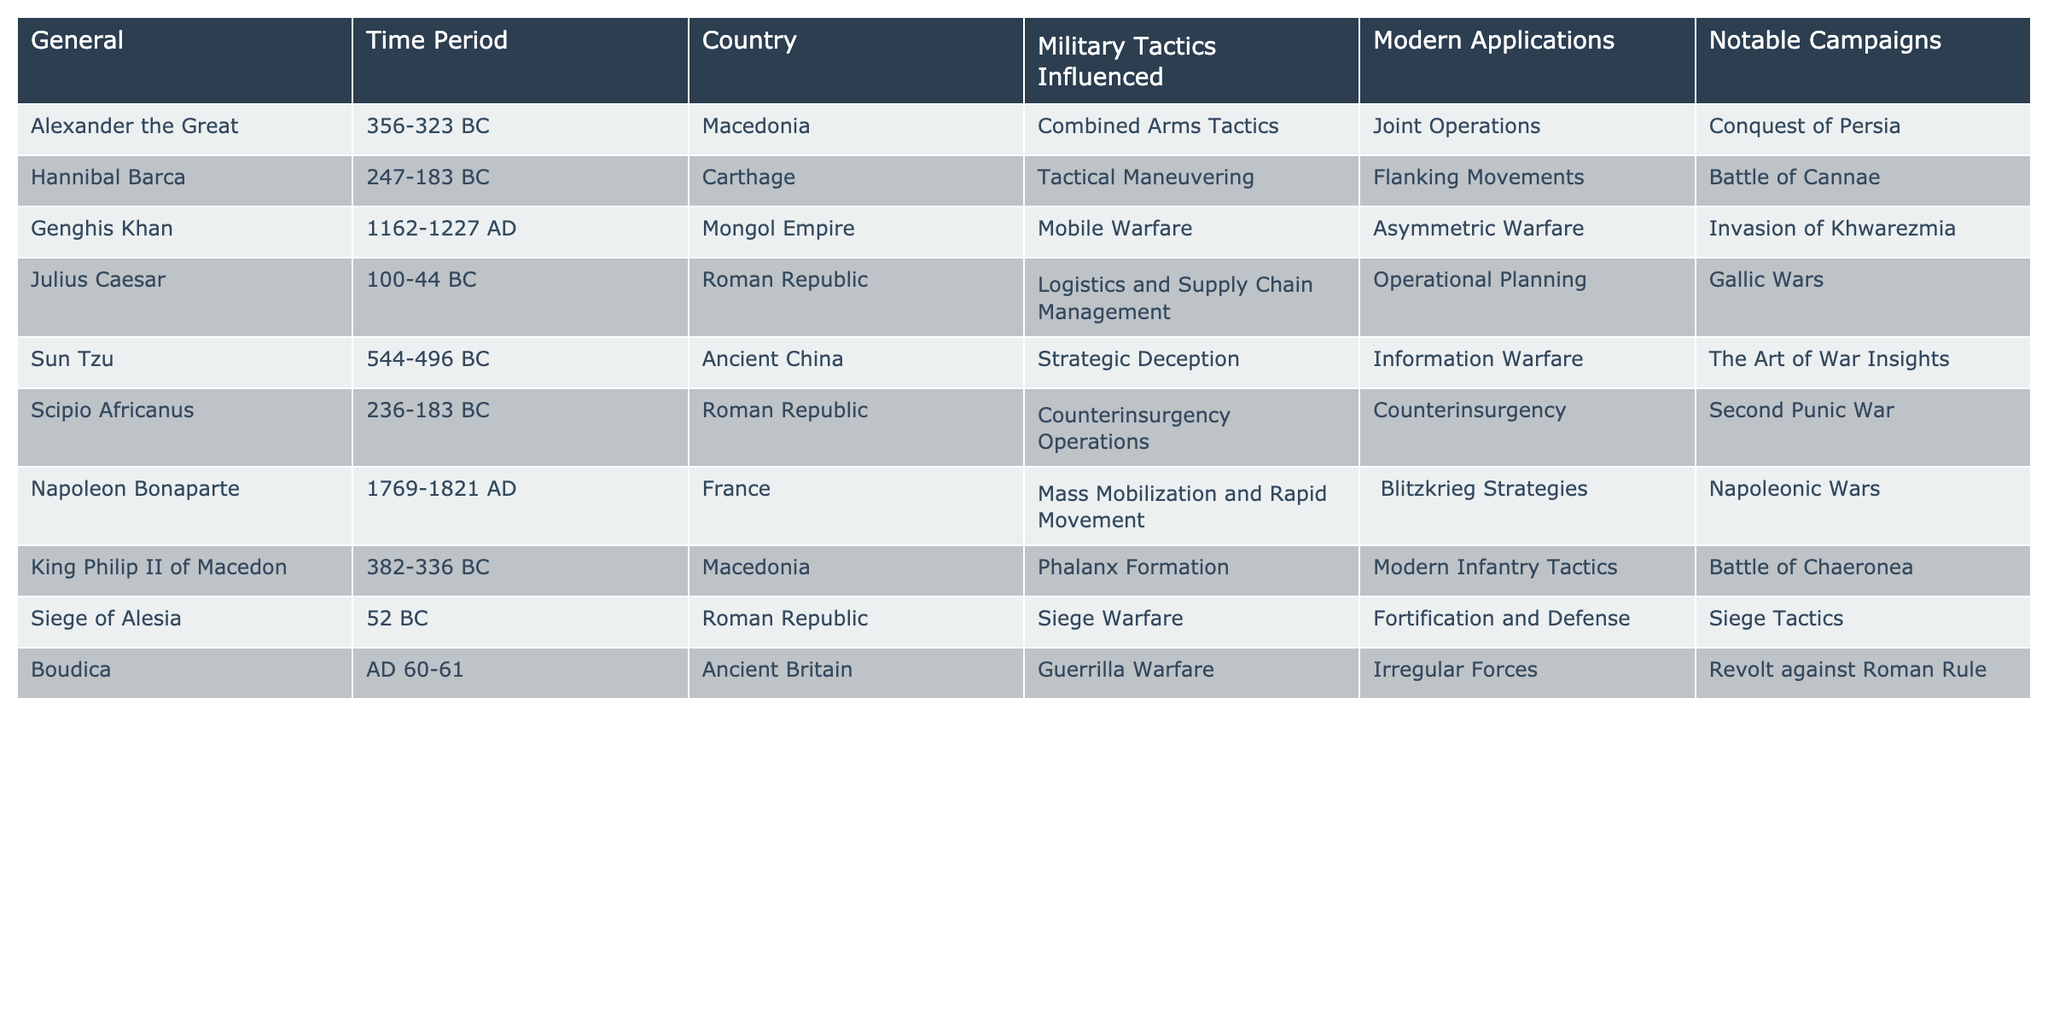What military tactic did Alexander the Great influence? According to the table, Alexander the Great influenced Combined Arms Tactics.
Answer: Combined Arms Tactics Which general is associated with the Battle of Cannae? The table shows that Hannibal Barca is associated with the Battle of Cannae.
Answer: Hannibal Barca What modern application is derived from the tactics of Genghis Khan? The table indicates that the modern application derived from Genghis Khan's tactics is Asymmetric Warfare.
Answer: Asymmetric Warfare Did Sun Tzu influence modern information warfare? The table confirms that Sun Tzu's tactics influenced Information Warfare, making the statement true.
Answer: True How many generals are associated with the Roman Republic? From the table, there are three generals associated with the Roman Republic: Julius Caesar, Scipio Africanus, and the commander during the Siege of Alesia.
Answer: Three What is the notable campaign associated with Boudica? The table lists the Revolt against Roman Rule as the notable campaign associated with Boudica.
Answer: Revolt against Roman Rule Which general's tactics are connected to modern infantry tactics? According to the table, King Philip II of Macedon is connected to modern infantry tactics through his tactics of Phalanx Formation.
Answer: King Philip II of Macedon Which general is linked to both Guerrilla Warfare and Irregular Forces? Boudica is linked to both Guerrilla Warfare and Irregular Forces as per the insights in the table.
Answer: Boudica Are the tactics developed by Napoleon Bonaparte utilized in any modern military strategies? Yes, the table states that his tactics of Mass Mobilization and Rapid Movement are applied in Blitzkrieg Strategies.
Answer: Yes Which notable campaigns influenced the evolution of siege tactics? The table indicates that the Siege of Alesia influenced the evolution of siege tactics.
Answer: Siege of Alesia Which general had the earliest active time period? The earliest active time period mentioned in the table is for Sun Tzu, who lived from 544 to 496 BC.
Answer: Sun Tzu What is the relationship between Scipio Africanus and counterinsurgency operations? The table shows Scipio Africanus is associated with Counterinsurgency Operations, specifically in the Second Punic War.
Answer: Second Punic War 